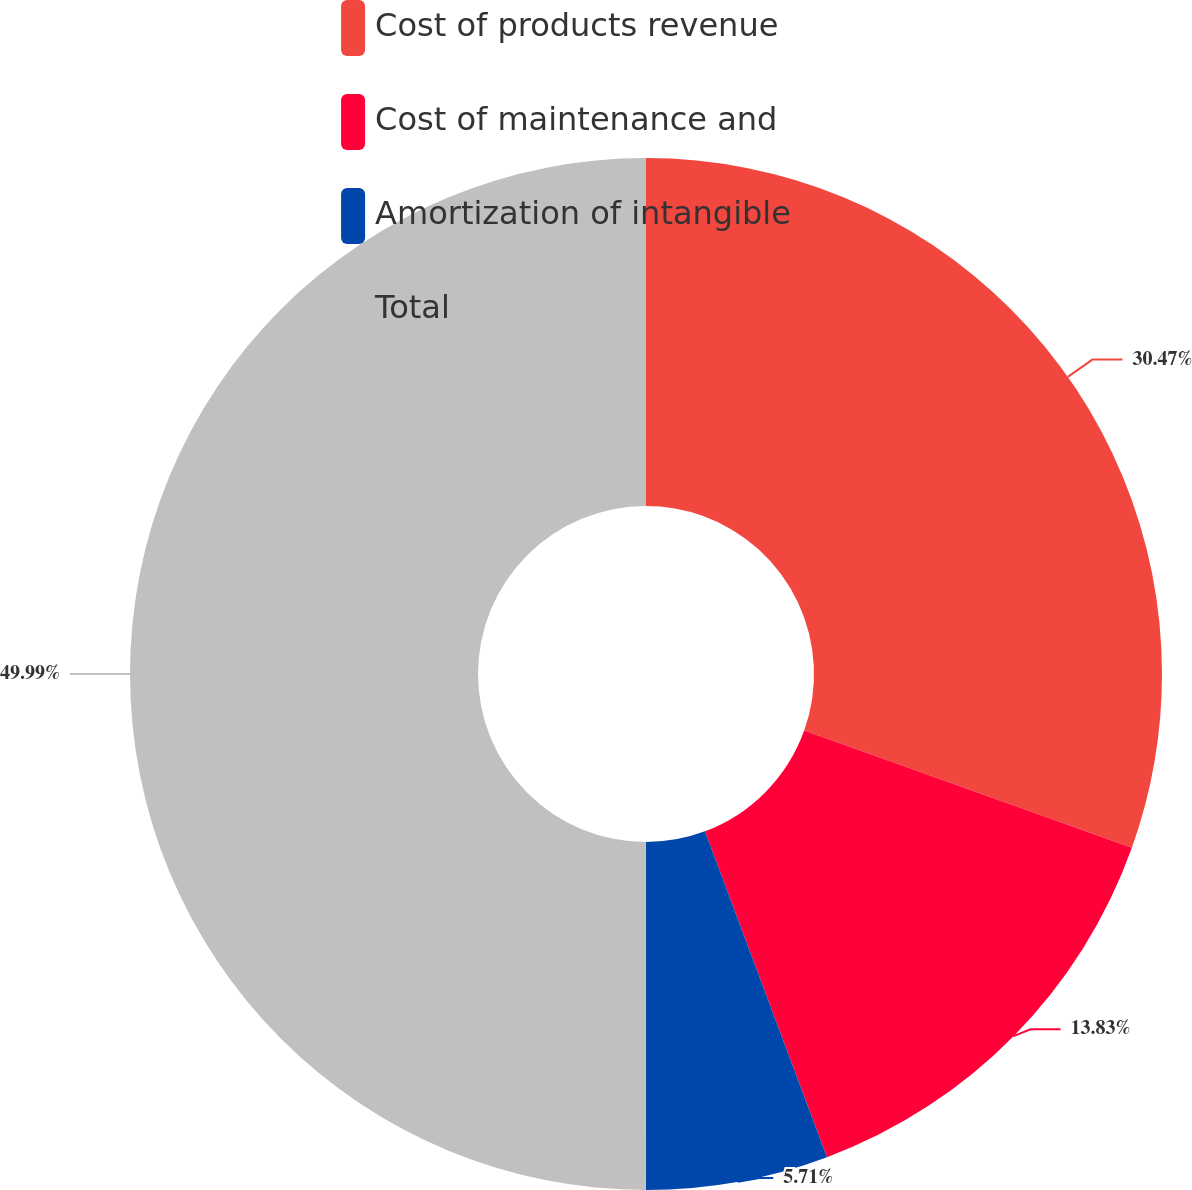Convert chart to OTSL. <chart><loc_0><loc_0><loc_500><loc_500><pie_chart><fcel>Cost of products revenue<fcel>Cost of maintenance and<fcel>Amortization of intangible<fcel>Total<nl><fcel>30.47%<fcel>13.83%<fcel>5.71%<fcel>50.0%<nl></chart> 